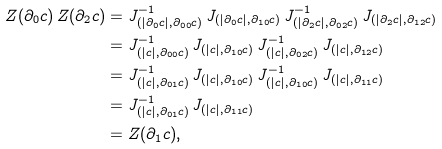<formula> <loc_0><loc_0><loc_500><loc_500>Z ( \partial _ { 0 } c ) \, Z ( \partial _ { 2 } c ) & = J ^ { - 1 } _ { ( | \partial _ { 0 } c | , \partial _ { 0 0 } c ) } \, J _ { ( | \partial _ { 0 } c | , \partial _ { 1 0 } c ) } \, J ^ { - 1 } _ { ( | \partial _ { 2 } c | , \partial _ { 0 2 } c ) } \, J _ { ( | \partial _ { 2 } c | , \partial _ { 1 2 } c ) } \\ & = J ^ { - 1 } _ { ( | c | , \partial _ { 0 0 } c ) } \, J _ { ( | c | , \partial _ { 1 0 } c ) } \, J ^ { - 1 } _ { ( | c | , \partial _ { 0 2 } c ) } \, J _ { ( | c | , \partial _ { 1 2 } c ) } \\ & = J ^ { - 1 } _ { ( | c | , \partial _ { 0 1 } c ) } \, J _ { ( | c | , \partial _ { 1 0 } c ) } \, J ^ { - 1 } _ { ( | c | , \partial _ { 1 0 } c ) } \, J _ { ( | c | , \partial _ { 1 1 } c ) } \\ & = J ^ { - 1 } _ { ( | c | , \partial _ { 0 1 } c ) } \, J _ { ( | c | , \partial _ { 1 1 } c ) } \\ & = Z ( \partial _ { 1 } c ) ,</formula> 